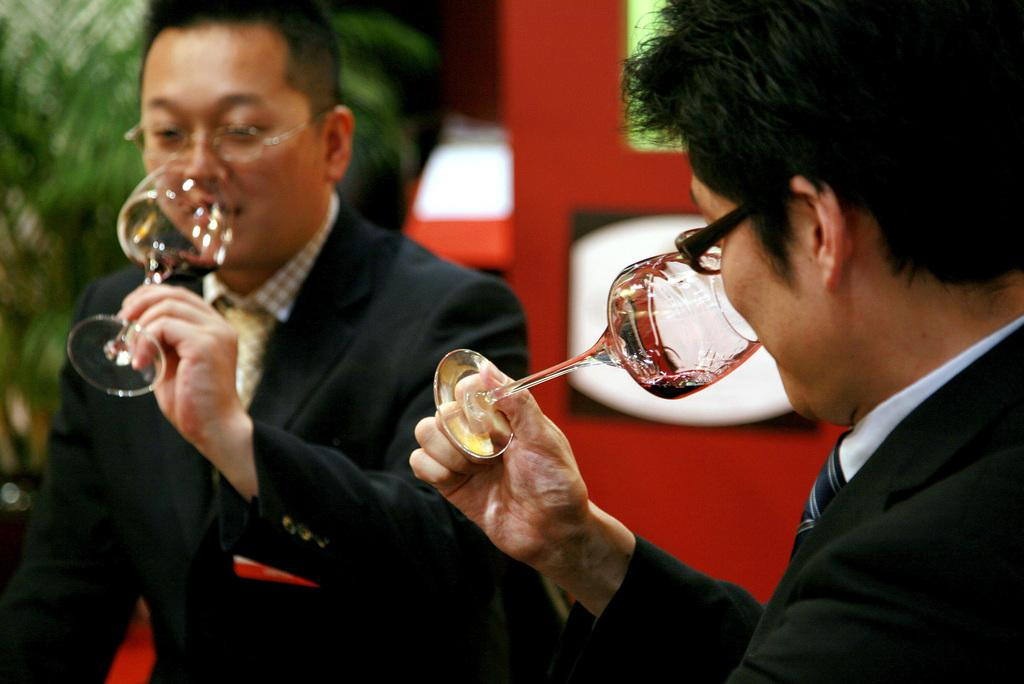How many people are in the image? There are two persons in the image. What are the persons holding in their hands? The persons are holding a glass in their hands. What can be seen in the background of the image? There are trees in the background of the image. What type of farm animals can be seen in the image? There are no farm animals present in the image. How does the yam move around in the image? There is no yam present in the image, so it cannot move around. 